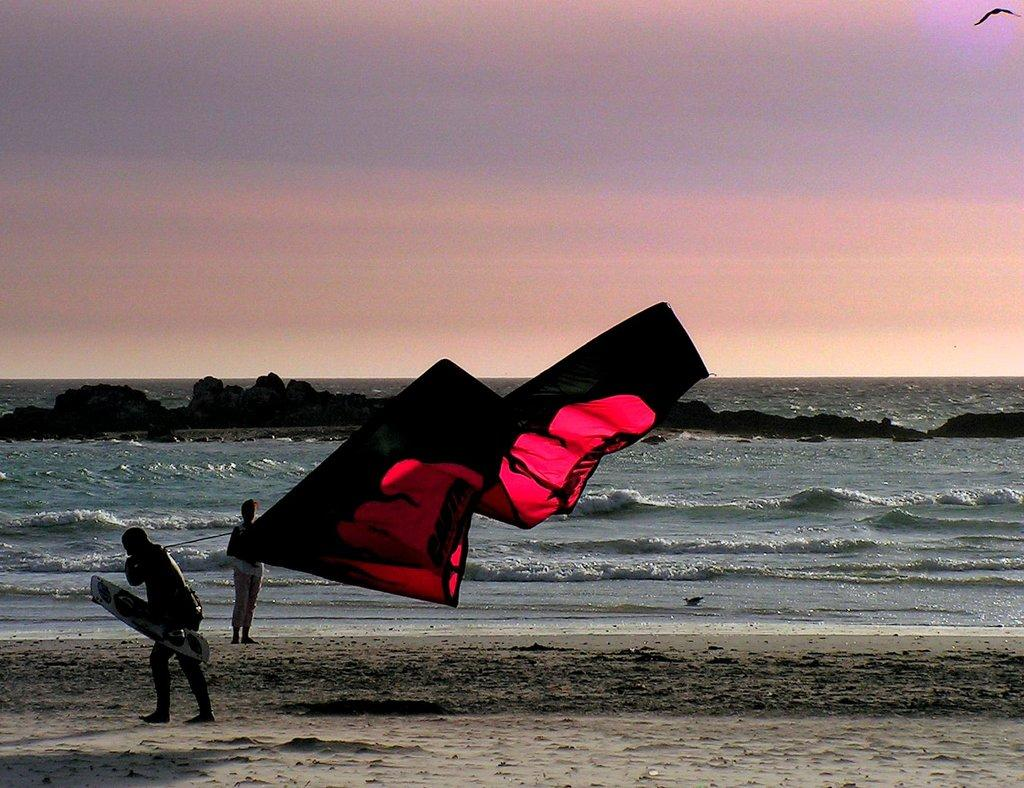What type of water body is shown in the image? The image depicts a freshwater river. What is the man holding in the image? The man is holding a surfboard in the image. What other object is present in the image? An air balloon is present in the image. Can you describe the person standing near the river? A person is standing in front of the river. What can be observed about the river's movement? Waves are visible in the river. What type of natural elements can be seen in the image? There are stones in the image. How does the person compare the size of the air balloon to the slip in the image? There is no slip present in the image, so it is not possible to make a comparison between the air balloon and a slip. 